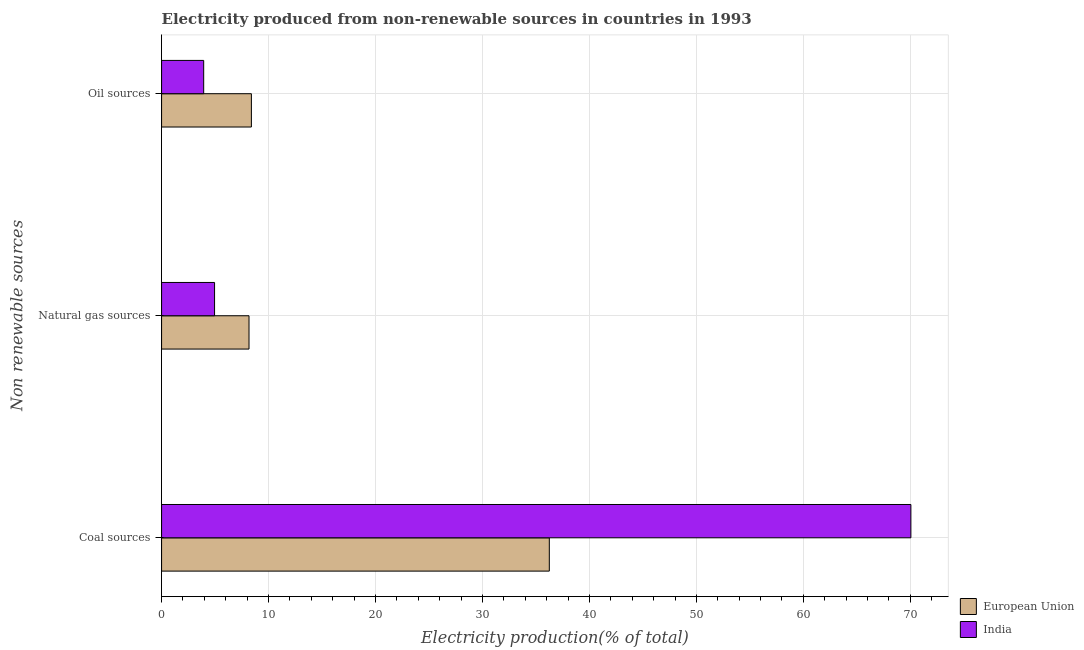How many groups of bars are there?
Offer a terse response. 3. Are the number of bars on each tick of the Y-axis equal?
Provide a short and direct response. Yes. How many bars are there on the 3rd tick from the top?
Offer a very short reply. 2. How many bars are there on the 1st tick from the bottom?
Make the answer very short. 2. What is the label of the 3rd group of bars from the top?
Your answer should be compact. Coal sources. What is the percentage of electricity produced by coal in India?
Your response must be concise. 70.05. Across all countries, what is the maximum percentage of electricity produced by oil sources?
Provide a short and direct response. 8.4. Across all countries, what is the minimum percentage of electricity produced by coal?
Your answer should be compact. 36.25. In which country was the percentage of electricity produced by oil sources minimum?
Give a very brief answer. India. What is the total percentage of electricity produced by oil sources in the graph?
Ensure brevity in your answer.  12.33. What is the difference between the percentage of electricity produced by oil sources in European Union and that in India?
Provide a short and direct response. 4.46. What is the difference between the percentage of electricity produced by coal in India and the percentage of electricity produced by natural gas in European Union?
Make the answer very short. 61.88. What is the average percentage of electricity produced by natural gas per country?
Your response must be concise. 6.56. What is the difference between the percentage of electricity produced by oil sources and percentage of electricity produced by coal in India?
Offer a terse response. -66.12. What is the ratio of the percentage of electricity produced by natural gas in India to that in European Union?
Ensure brevity in your answer.  0.61. Is the percentage of electricity produced by oil sources in India less than that in European Union?
Offer a terse response. Yes. What is the difference between the highest and the second highest percentage of electricity produced by coal?
Ensure brevity in your answer.  33.8. What is the difference between the highest and the lowest percentage of electricity produced by natural gas?
Your response must be concise. 3.22. Is the sum of the percentage of electricity produced by coal in European Union and India greater than the maximum percentage of electricity produced by natural gas across all countries?
Your answer should be very brief. Yes. What does the 2nd bar from the top in Coal sources represents?
Your answer should be compact. European Union. What does the 2nd bar from the bottom in Coal sources represents?
Make the answer very short. India. Is it the case that in every country, the sum of the percentage of electricity produced by coal and percentage of electricity produced by natural gas is greater than the percentage of electricity produced by oil sources?
Offer a terse response. Yes. How many bars are there?
Offer a very short reply. 6. Are all the bars in the graph horizontal?
Offer a terse response. Yes. How many countries are there in the graph?
Your answer should be compact. 2. Are the values on the major ticks of X-axis written in scientific E-notation?
Provide a short and direct response. No. Does the graph contain any zero values?
Your answer should be compact. No. Does the graph contain grids?
Give a very brief answer. Yes. How many legend labels are there?
Keep it short and to the point. 2. What is the title of the graph?
Offer a terse response. Electricity produced from non-renewable sources in countries in 1993. What is the label or title of the Y-axis?
Make the answer very short. Non renewable sources. What is the Electricity production(% of total) of European Union in Coal sources?
Ensure brevity in your answer.  36.25. What is the Electricity production(% of total) in India in Coal sources?
Provide a succinct answer. 70.05. What is the Electricity production(% of total) of European Union in Natural gas sources?
Offer a terse response. 8.17. What is the Electricity production(% of total) of India in Natural gas sources?
Make the answer very short. 4.95. What is the Electricity production(% of total) of European Union in Oil sources?
Provide a short and direct response. 8.4. What is the Electricity production(% of total) in India in Oil sources?
Keep it short and to the point. 3.94. Across all Non renewable sources, what is the maximum Electricity production(% of total) of European Union?
Make the answer very short. 36.25. Across all Non renewable sources, what is the maximum Electricity production(% of total) of India?
Your response must be concise. 70.05. Across all Non renewable sources, what is the minimum Electricity production(% of total) in European Union?
Offer a very short reply. 8.17. Across all Non renewable sources, what is the minimum Electricity production(% of total) of India?
Ensure brevity in your answer.  3.94. What is the total Electricity production(% of total) in European Union in the graph?
Ensure brevity in your answer.  52.82. What is the total Electricity production(% of total) of India in the graph?
Provide a short and direct response. 78.95. What is the difference between the Electricity production(% of total) of European Union in Coal sources and that in Natural gas sources?
Give a very brief answer. 28.08. What is the difference between the Electricity production(% of total) in India in Coal sources and that in Natural gas sources?
Offer a terse response. 65.1. What is the difference between the Electricity production(% of total) in European Union in Coal sources and that in Oil sources?
Keep it short and to the point. 27.85. What is the difference between the Electricity production(% of total) of India in Coal sources and that in Oil sources?
Your answer should be very brief. 66.12. What is the difference between the Electricity production(% of total) of European Union in Natural gas sources and that in Oil sources?
Your answer should be very brief. -0.22. What is the difference between the Electricity production(% of total) of India in Natural gas sources and that in Oil sources?
Your answer should be compact. 1.02. What is the difference between the Electricity production(% of total) in European Union in Coal sources and the Electricity production(% of total) in India in Natural gas sources?
Your response must be concise. 31.3. What is the difference between the Electricity production(% of total) in European Union in Coal sources and the Electricity production(% of total) in India in Oil sources?
Offer a very short reply. 32.31. What is the difference between the Electricity production(% of total) in European Union in Natural gas sources and the Electricity production(% of total) in India in Oil sources?
Your answer should be very brief. 4.24. What is the average Electricity production(% of total) in European Union per Non renewable sources?
Provide a short and direct response. 17.61. What is the average Electricity production(% of total) of India per Non renewable sources?
Ensure brevity in your answer.  26.32. What is the difference between the Electricity production(% of total) of European Union and Electricity production(% of total) of India in Coal sources?
Your answer should be compact. -33.8. What is the difference between the Electricity production(% of total) of European Union and Electricity production(% of total) of India in Natural gas sources?
Make the answer very short. 3.22. What is the difference between the Electricity production(% of total) in European Union and Electricity production(% of total) in India in Oil sources?
Give a very brief answer. 4.46. What is the ratio of the Electricity production(% of total) of European Union in Coal sources to that in Natural gas sources?
Keep it short and to the point. 4.43. What is the ratio of the Electricity production(% of total) in India in Coal sources to that in Natural gas sources?
Make the answer very short. 14.14. What is the ratio of the Electricity production(% of total) in European Union in Coal sources to that in Oil sources?
Your response must be concise. 4.32. What is the ratio of the Electricity production(% of total) of India in Coal sources to that in Oil sources?
Your response must be concise. 17.79. What is the ratio of the Electricity production(% of total) of European Union in Natural gas sources to that in Oil sources?
Offer a very short reply. 0.97. What is the ratio of the Electricity production(% of total) in India in Natural gas sources to that in Oil sources?
Ensure brevity in your answer.  1.26. What is the difference between the highest and the second highest Electricity production(% of total) of European Union?
Your response must be concise. 27.85. What is the difference between the highest and the second highest Electricity production(% of total) in India?
Offer a very short reply. 65.1. What is the difference between the highest and the lowest Electricity production(% of total) of European Union?
Your response must be concise. 28.08. What is the difference between the highest and the lowest Electricity production(% of total) of India?
Keep it short and to the point. 66.12. 